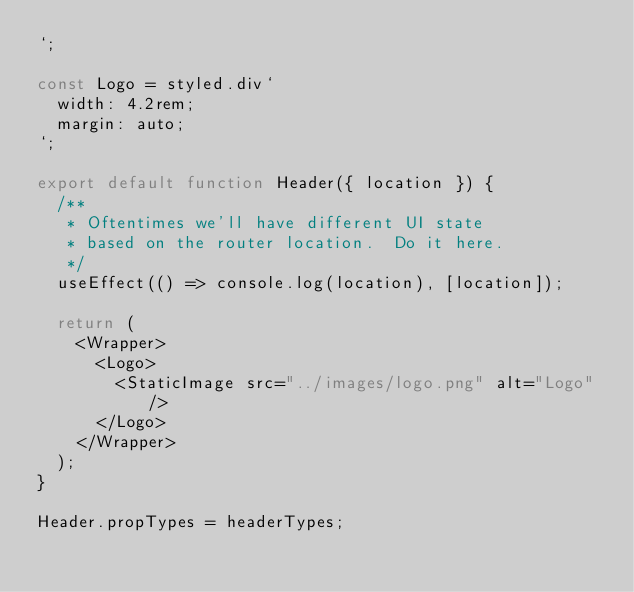Convert code to text. <code><loc_0><loc_0><loc_500><loc_500><_JavaScript_>`;

const Logo = styled.div`
  width: 4.2rem;
  margin: auto;
`;

export default function Header({ location }) {
  /**
   * Oftentimes we'll have different UI state
   * based on the router location.  Do it here.
   */
  useEffect(() => console.log(location), [location]);

  return (
    <Wrapper>
      <Logo>
        <StaticImage src="../images/logo.png" alt="Logo" />
      </Logo>
    </Wrapper>
  );
}

Header.propTypes = headerTypes;
</code> 